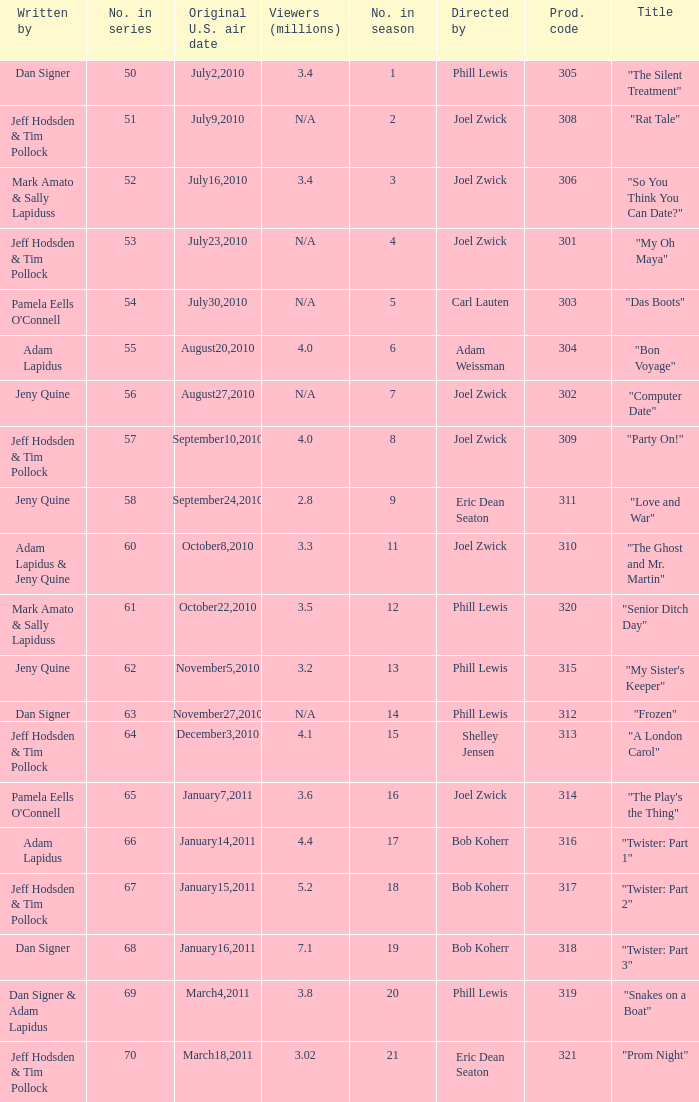Who was the directed for the episode titled "twister: part 1"? Bob Koherr. 